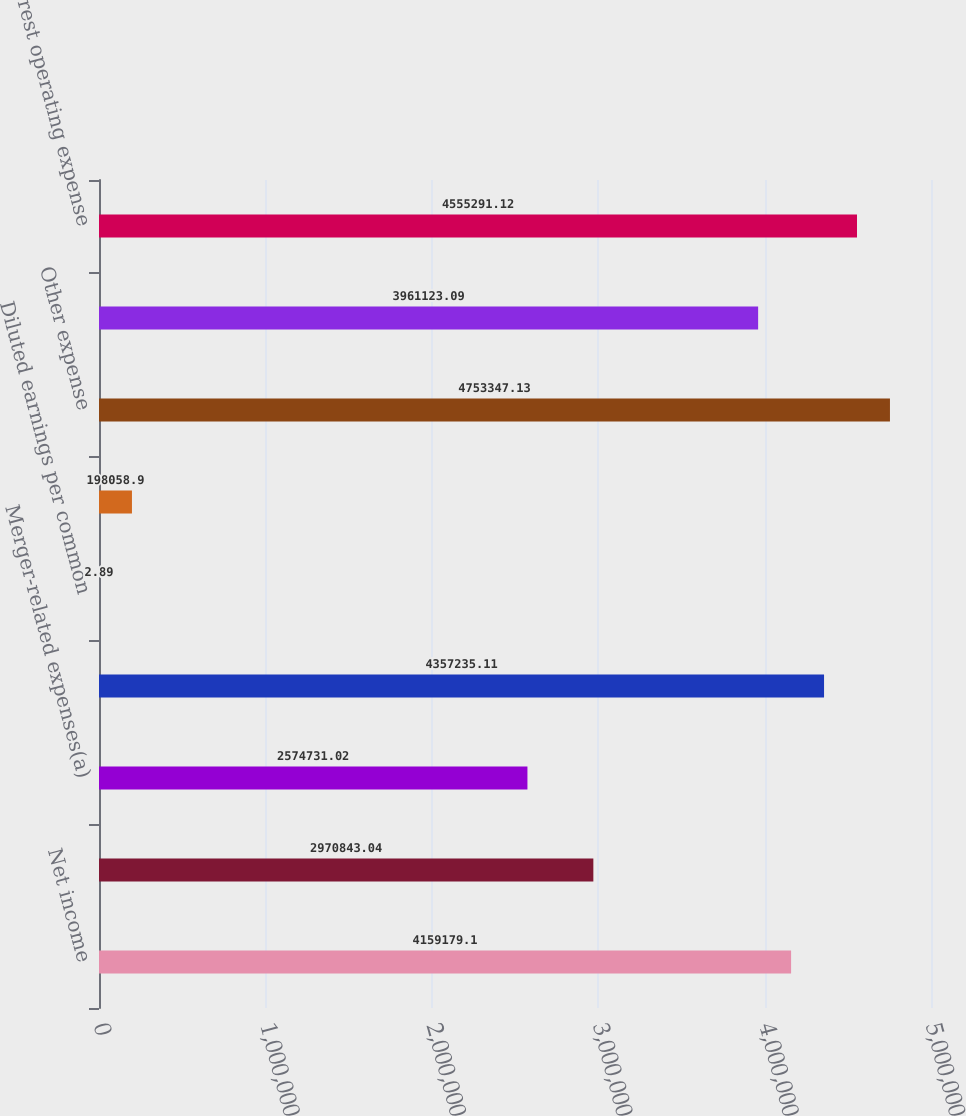Convert chart. <chart><loc_0><loc_0><loc_500><loc_500><bar_chart><fcel>Net income<fcel>Amortization of core deposit<fcel>Merger-related expenses(a)<fcel>Net operating income<fcel>Diluted earnings per common<fcel>Diluted net operating earnings<fcel>Other expense<fcel>Merger-related expenses<fcel>Noninterest operating expense<nl><fcel>4.15918e+06<fcel>2.97084e+06<fcel>2.57473e+06<fcel>4.35724e+06<fcel>2.89<fcel>198059<fcel>4.75335e+06<fcel>3.96112e+06<fcel>4.55529e+06<nl></chart> 